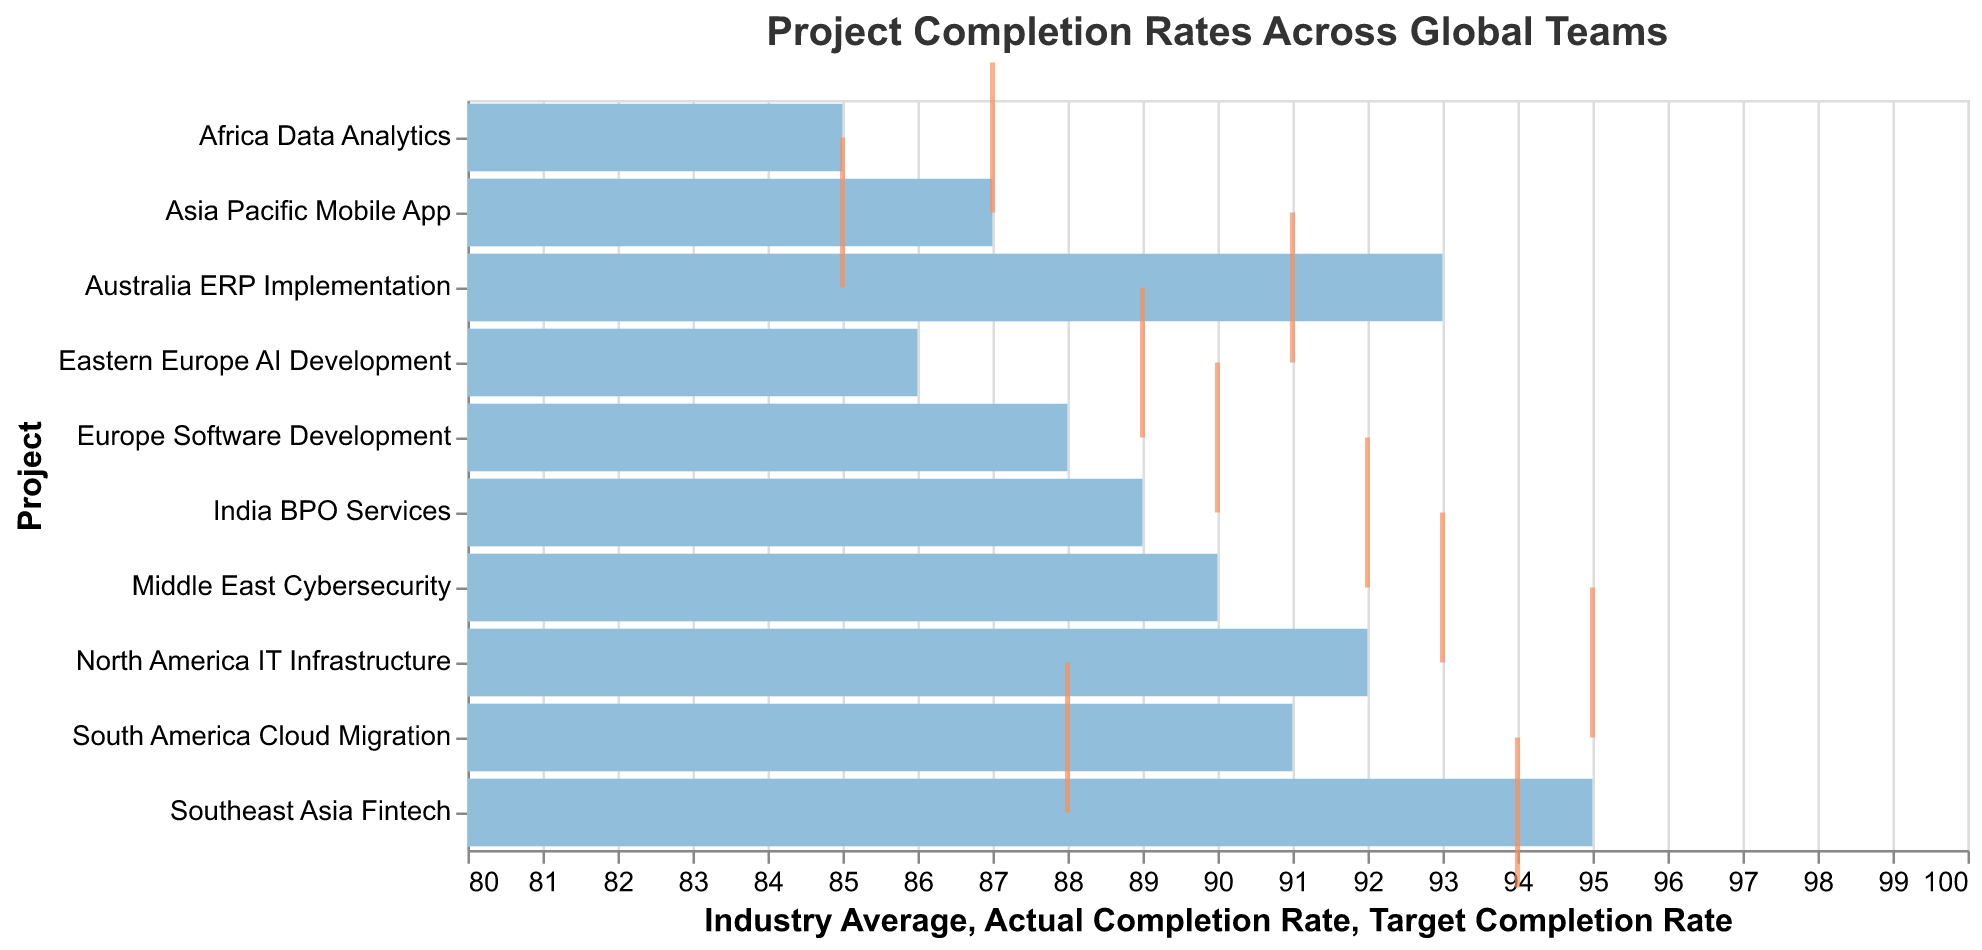Which project has the highest actual completion rate? The Southeast Asia Fintech project has the highest actual completion rate, indicated by the bar reaching 95 on the horizontal axis.
Answer: Southeast Asia Fintech Which project had the lowest actual completion rate? The Africa Data Analytics project had the lowest actual completion rate, indicated by the bar reaching 85 on the horizontal axis.
Answer: Africa Data Analytics Is there any project where the actual completion rate exceeds the target completion rate? Yes, two projects have actual completion rates exceeding their targets: Southeast Asia Fintech (95 vs. 94) and South America Cloud Migration (91 vs. 88).
Answer: Southeast Asia Fintech, South America Cloud Migration How many projects have an actual completion rate that meets or exceeds the industry average? By comparing the actual completion rate bars with the industry average bars, we find that 7 projects meet or exceed the industry average.
Answer: 7 Which project has the smallest gap between the target and actual completion rates? The Southeast Asia Fintech project has the smallest gap, with the actual completion rate exceeding the target by 1 (95 vs. 94).
Answer: Southeast Asia Fintech What is the average target completion rate across all projects? Sum all target completion rates (95 + 90 + 85 + 92 + 88 + 93 + 87 + 91 + 89 + 94) which equals 904, then divide by the number of projects, 10.
Answer: 90.4 What fraction of the projects have an actual completion rate below the target? By counting the projects with a bar shorter than the tick marks, we observe that 6 out of 10 projects have actual completion rates below their target rates.
Answer: 6/10 or 3/5 Which regions have an actual completion rate that is 2 or more points higher than their industry average? By comparing the bars for actual completion rate and industry average, Asia Pacific Mobile App (87 vs 82), South America Cloud Migration (91 vs 84), Southeast Asia Fintech (95 vs 90), Africa Data Analytics (85 vs 81), and Australia ERP Implementation (93 vs 88) meet this criterion.
Answer: Asia Pacific Mobile App, South America Cloud Migration, Southeast Asia Fintech, Africa Data Analytics, Australia ERP Implementation 